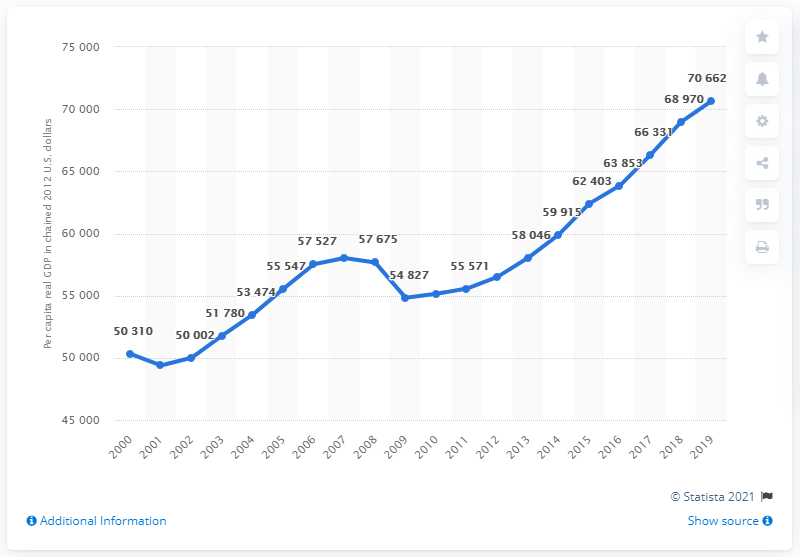List a handful of essential elements in this visual. The highest Gross Domestic Product (GDP) that California has ever had was 70,662 billion dollars. California's Gross Domestic Product (GDP) decreased by 28.48% from 2008 to 2009. In 2012, the per capita real GDP of California stood at 70,662 chained. 